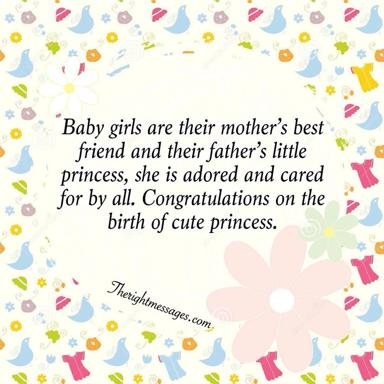Can you describe the visual design of the image? The image features a lively and charming background with a pattern of small, stylized birds and whimsical flowers spread across a light yellow field, dotted with multi-colored accents. These playful elements create an inviting and joyful atmosphere, effectively complementing the message of celebration for the new arrival. The design uses a palette of soft pastels to evoke a sense of warmth and gentleness, apt for the occasion. 